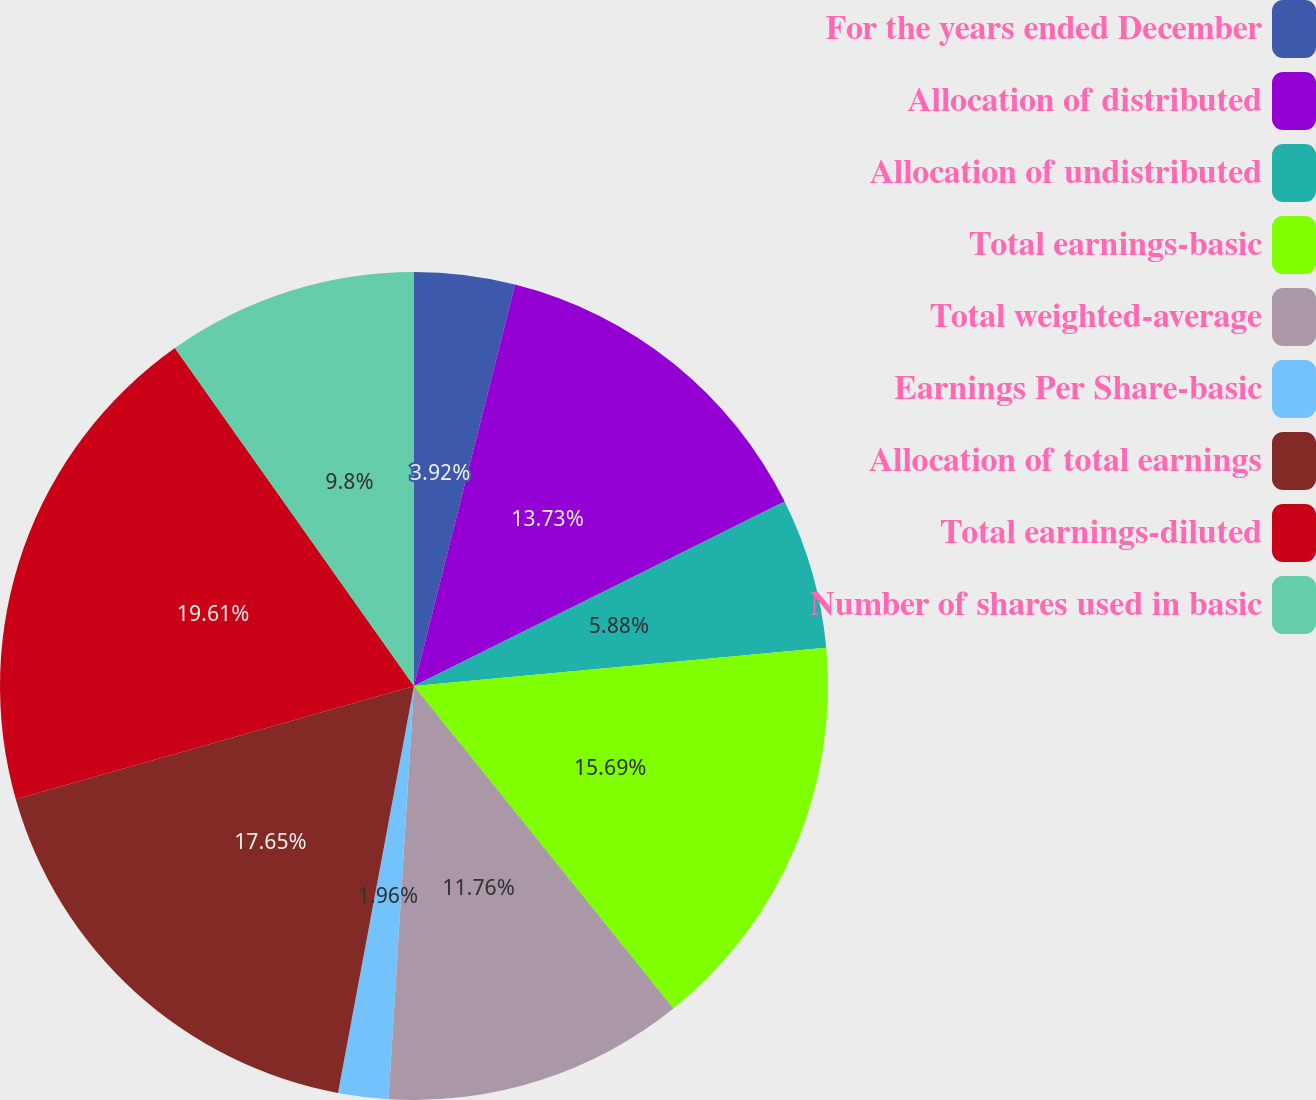Convert chart. <chart><loc_0><loc_0><loc_500><loc_500><pie_chart><fcel>For the years ended December<fcel>Allocation of distributed<fcel>Allocation of undistributed<fcel>Total earnings-basic<fcel>Total weighted-average<fcel>Earnings Per Share-basic<fcel>Allocation of total earnings<fcel>Total earnings-diluted<fcel>Number of shares used in basic<nl><fcel>3.92%<fcel>13.73%<fcel>5.88%<fcel>15.69%<fcel>11.76%<fcel>1.96%<fcel>17.65%<fcel>19.61%<fcel>9.8%<nl></chart> 